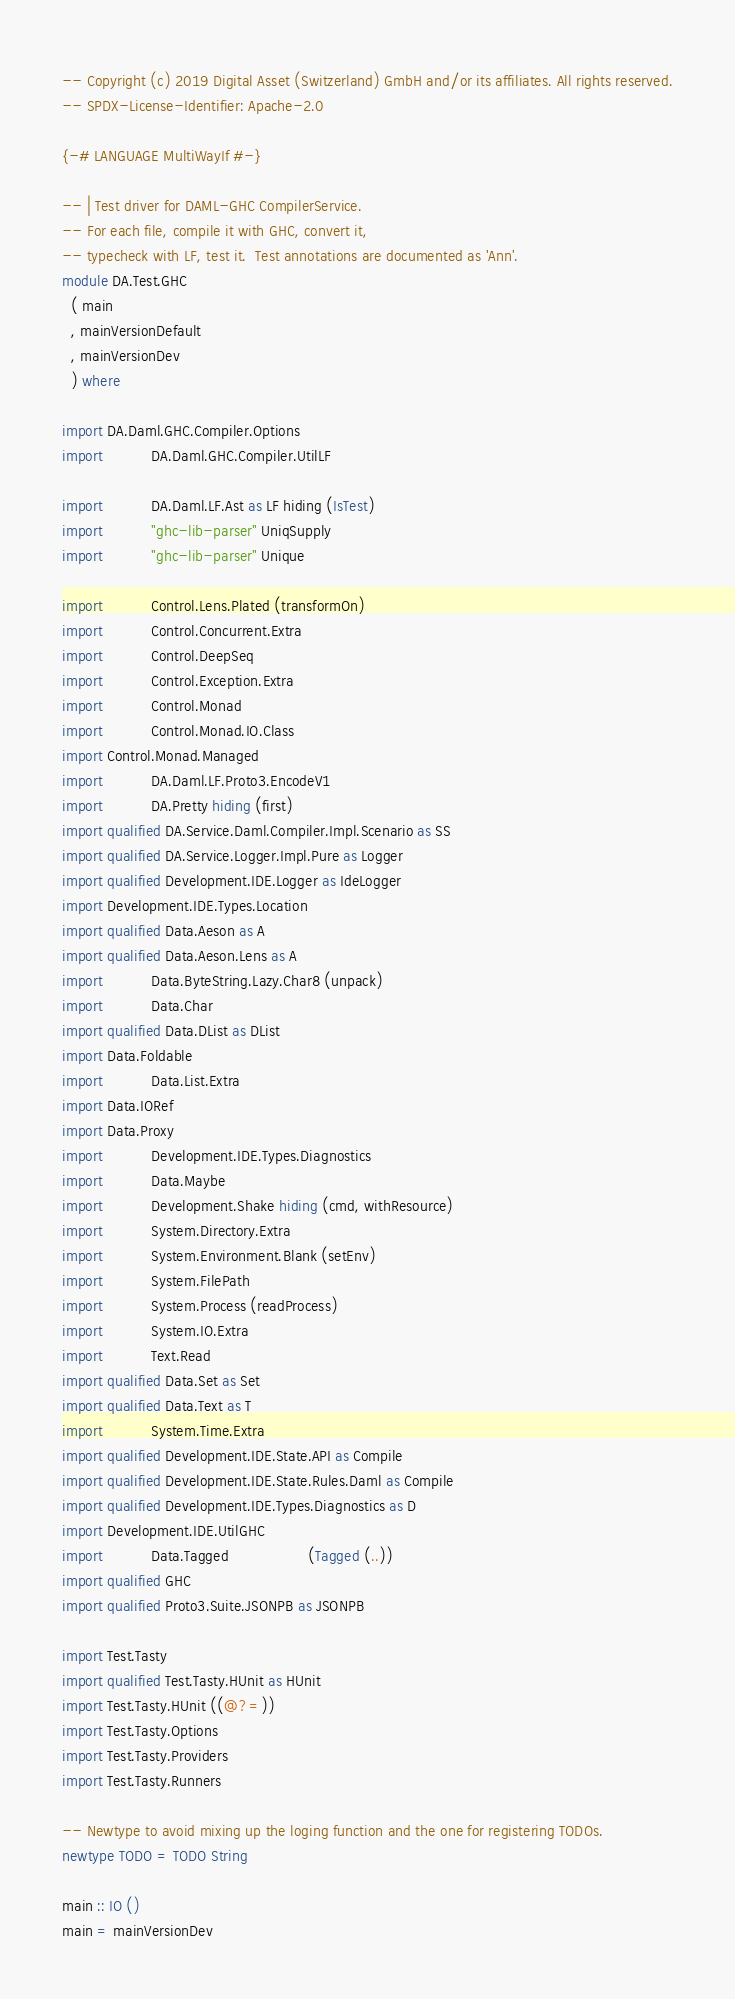<code> <loc_0><loc_0><loc_500><loc_500><_Haskell_>-- Copyright (c) 2019 Digital Asset (Switzerland) GmbH and/or its affiliates. All rights reserved.
-- SPDX-License-Identifier: Apache-2.0

{-# LANGUAGE MultiWayIf #-}

-- | Test driver for DAML-GHC CompilerService.
-- For each file, compile it with GHC, convert it,
-- typecheck with LF, test it.  Test annotations are documented as 'Ann'.
module DA.Test.GHC
  ( main
  , mainVersionDefault
  , mainVersionDev
  ) where

import DA.Daml.GHC.Compiler.Options
import           DA.Daml.GHC.Compiler.UtilLF

import           DA.Daml.LF.Ast as LF hiding (IsTest)
import           "ghc-lib-parser" UniqSupply
import           "ghc-lib-parser" Unique

import           Control.Lens.Plated (transformOn)
import           Control.Concurrent.Extra
import           Control.DeepSeq
import           Control.Exception.Extra
import           Control.Monad
import           Control.Monad.IO.Class
import Control.Monad.Managed
import           DA.Daml.LF.Proto3.EncodeV1
import           DA.Pretty hiding (first)
import qualified DA.Service.Daml.Compiler.Impl.Scenario as SS
import qualified DA.Service.Logger.Impl.Pure as Logger
import qualified Development.IDE.Logger as IdeLogger
import Development.IDE.Types.Location
import qualified Data.Aeson as A
import qualified Data.Aeson.Lens as A
import           Data.ByteString.Lazy.Char8 (unpack)
import           Data.Char
import qualified Data.DList as DList
import Data.Foldable
import           Data.List.Extra
import Data.IORef
import Data.Proxy
import           Development.IDE.Types.Diagnostics
import           Data.Maybe
import           Development.Shake hiding (cmd, withResource)
import           System.Directory.Extra
import           System.Environment.Blank (setEnv)
import           System.FilePath
import           System.Process (readProcess)
import           System.IO.Extra
import           Text.Read
import qualified Data.Set as Set
import qualified Data.Text as T
import           System.Time.Extra
import qualified Development.IDE.State.API as Compile
import qualified Development.IDE.State.Rules.Daml as Compile
import qualified Development.IDE.Types.Diagnostics as D
import Development.IDE.UtilGHC
import           Data.Tagged                  (Tagged (..))
import qualified GHC
import qualified Proto3.Suite.JSONPB as JSONPB

import Test.Tasty
import qualified Test.Tasty.HUnit as HUnit
import Test.Tasty.HUnit ((@?=))
import Test.Tasty.Options
import Test.Tasty.Providers
import Test.Tasty.Runners

-- Newtype to avoid mixing up the loging function and the one for registering TODOs.
newtype TODO = TODO String

main :: IO ()
main = mainVersionDev
</code> 